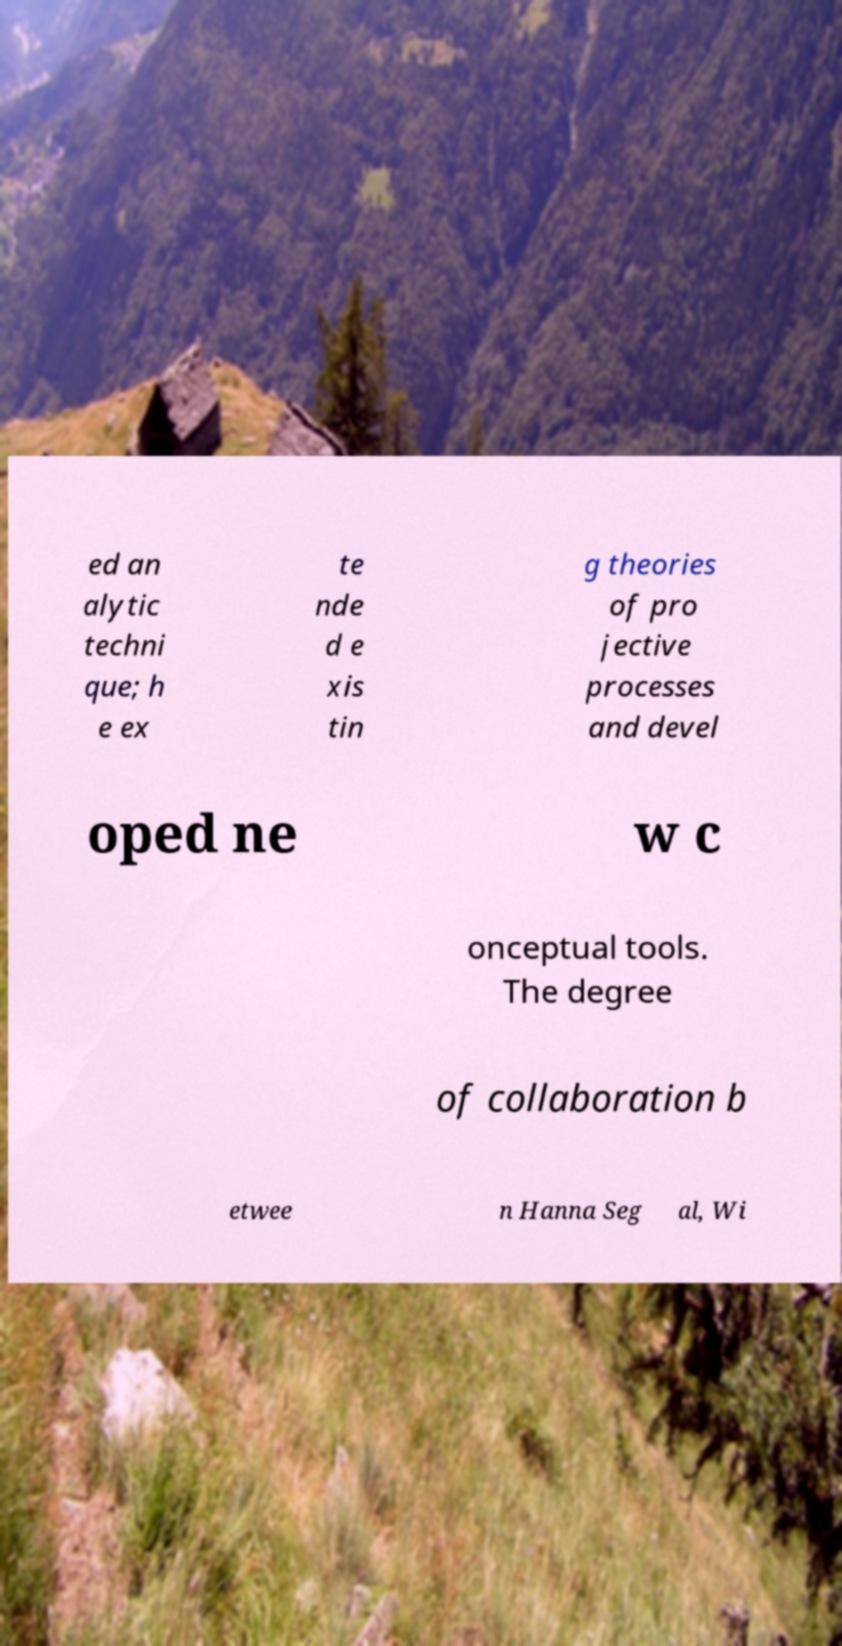For documentation purposes, I need the text within this image transcribed. Could you provide that? ed an alytic techni que; h e ex te nde d e xis tin g theories of pro jective processes and devel oped ne w c onceptual tools. The degree of collaboration b etwee n Hanna Seg al, Wi 